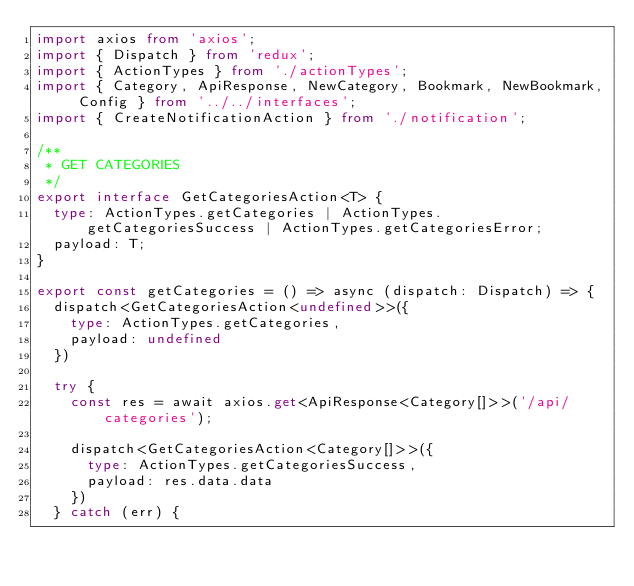<code> <loc_0><loc_0><loc_500><loc_500><_TypeScript_>import axios from 'axios';
import { Dispatch } from 'redux';
import { ActionTypes } from './actionTypes';
import { Category, ApiResponse, NewCategory, Bookmark, NewBookmark, Config } from '../../interfaces';
import { CreateNotificationAction } from './notification';

/**
 * GET CATEGORIES
 */
export interface GetCategoriesAction<T> {
  type: ActionTypes.getCategories | ActionTypes.getCategoriesSuccess | ActionTypes.getCategoriesError;
  payload: T;
}

export const getCategories = () => async (dispatch: Dispatch) => {
  dispatch<GetCategoriesAction<undefined>>({
    type: ActionTypes.getCategories,
    payload: undefined
  })

  try {
    const res = await axios.get<ApiResponse<Category[]>>('/api/categories');

    dispatch<GetCategoriesAction<Category[]>>({
      type: ActionTypes.getCategoriesSuccess,
      payload: res.data.data
    })
  } catch (err) {</code> 